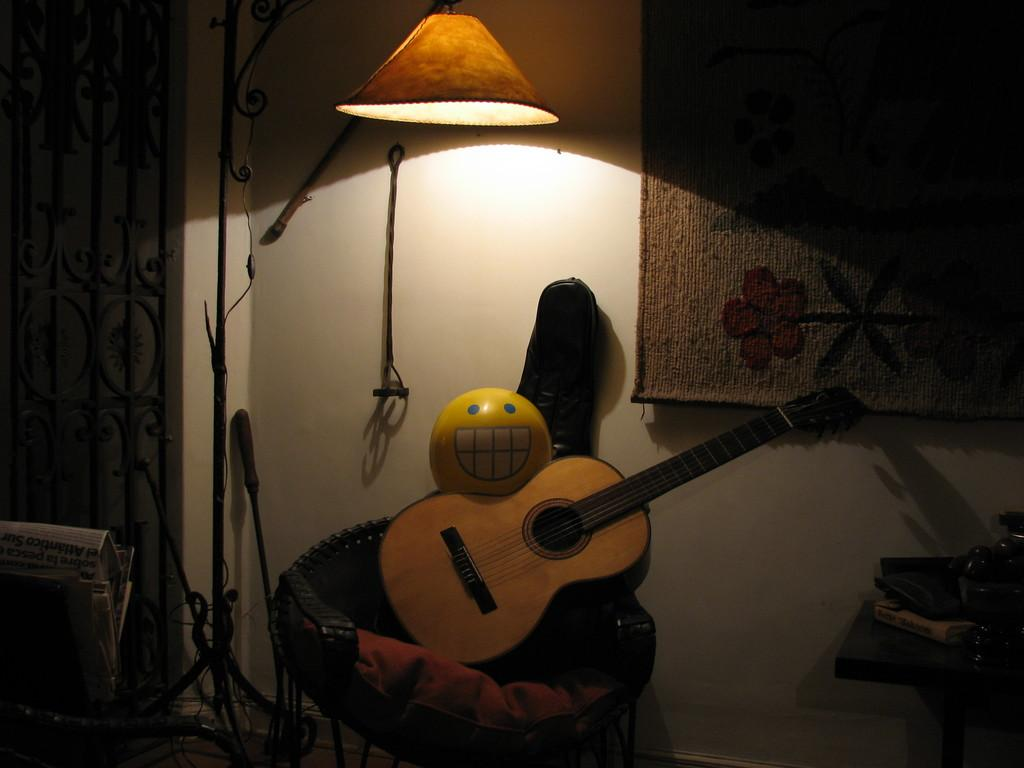What musical instrument is present in the image? There is a guitar in the image. What else can be seen in the image besides the guitar? There are other objects in the image. Can you describe one of the other objects in the image? There is a lamp in the image. What type of ball is being used in the game in the image? There is no ball or game present in the image; it features a guitar and other objects. Can you tell me the name of the brother in the image? There is no person or brother mentioned in the image; it only features a guitar and other objects. 